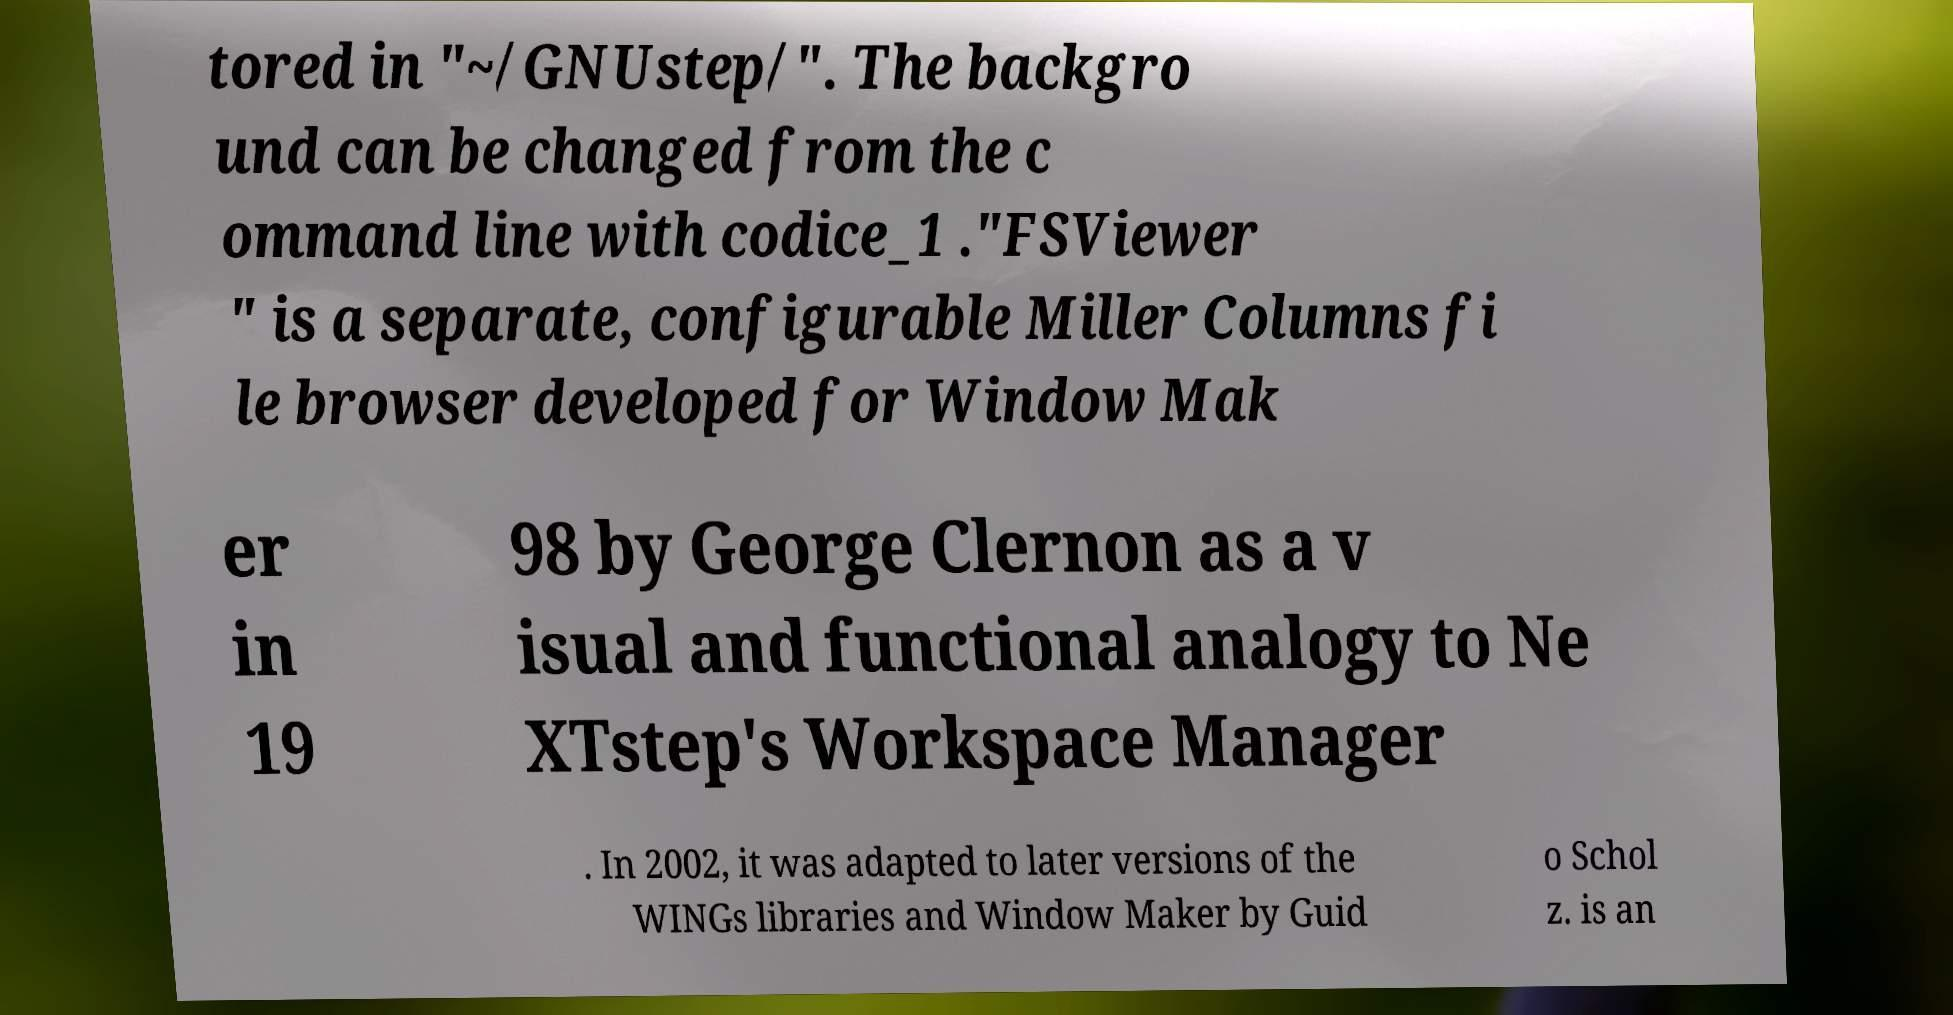Can you accurately transcribe the text from the provided image for me? tored in "~/GNUstep/". The backgro und can be changed from the c ommand line with codice_1 ."FSViewer " is a separate, configurable Miller Columns fi le browser developed for Window Mak er in 19 98 by George Clernon as a v isual and functional analogy to Ne XTstep's Workspace Manager . In 2002, it was adapted to later versions of the WINGs libraries and Window Maker by Guid o Schol z. is an 